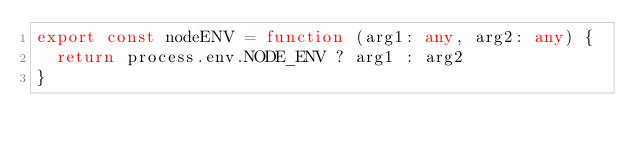Convert code to text. <code><loc_0><loc_0><loc_500><loc_500><_TypeScript_>export const nodeENV = function (arg1: any, arg2: any) {
  return process.env.NODE_ENV ? arg1 : arg2
}
</code> 